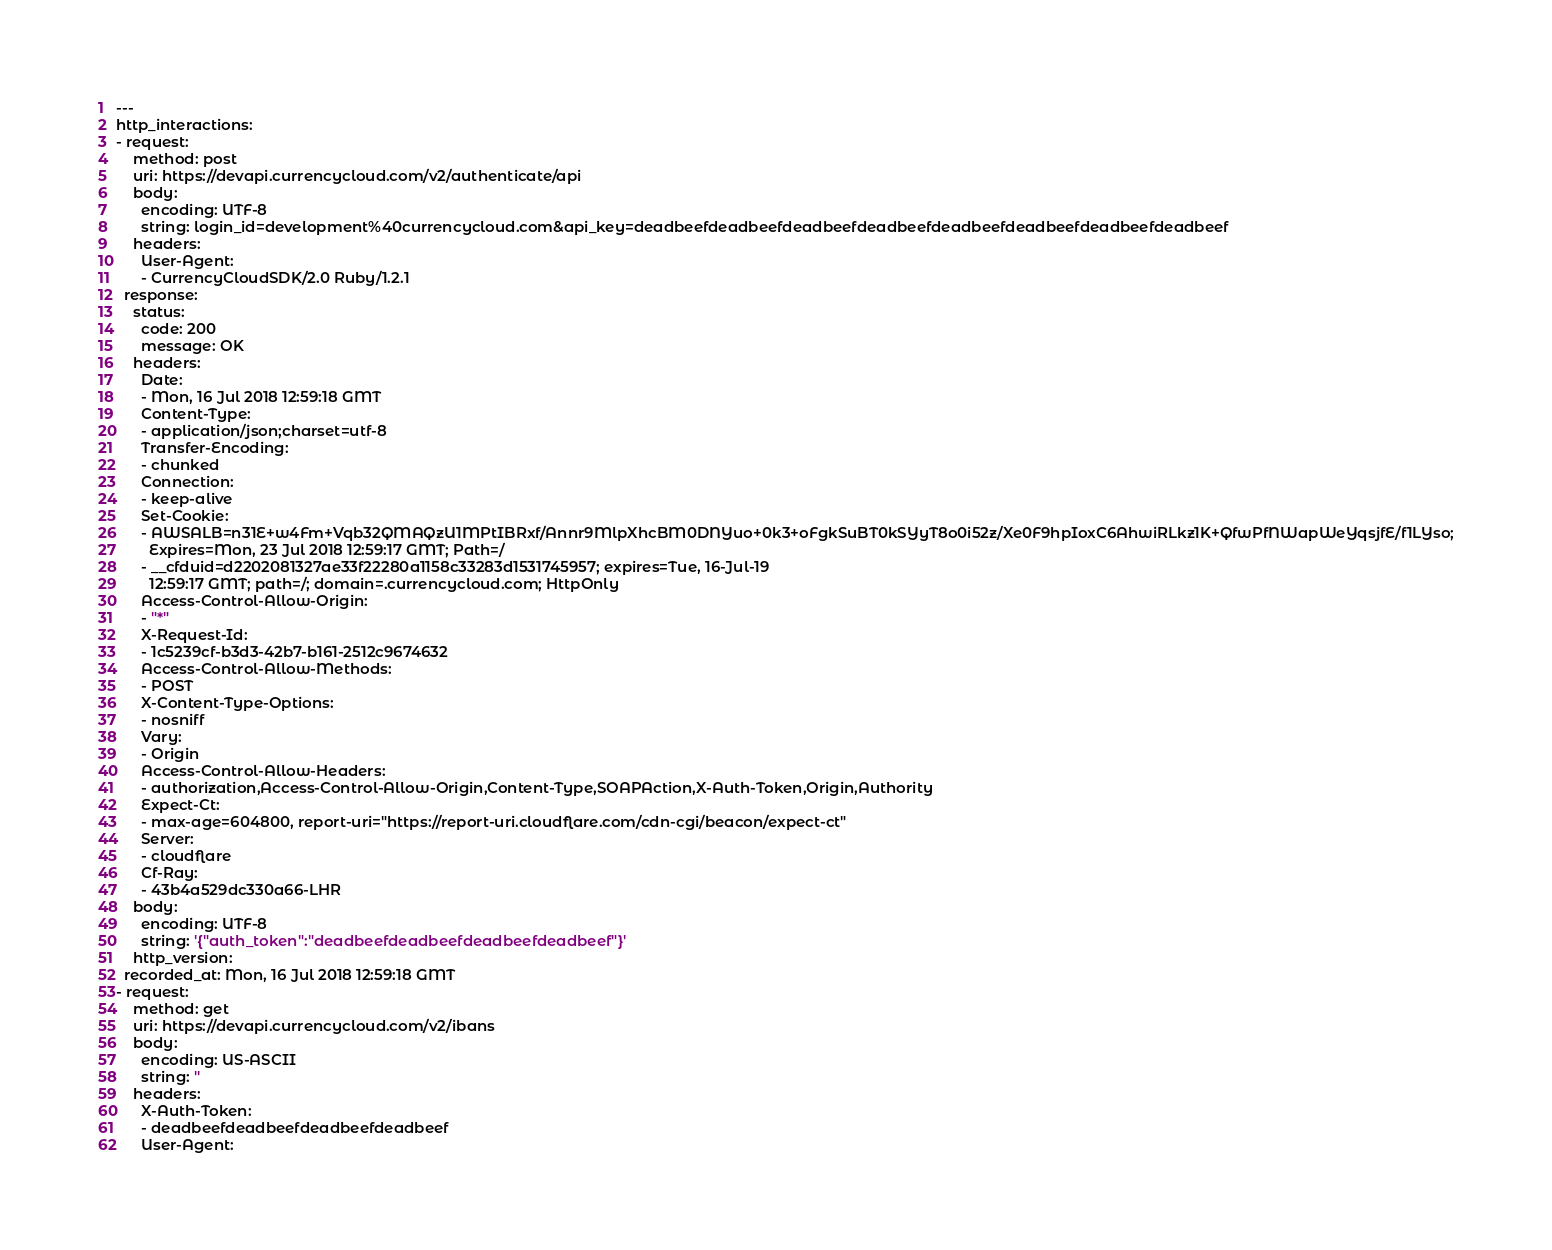Convert code to text. <code><loc_0><loc_0><loc_500><loc_500><_YAML_>---
http_interactions:
- request:
    method: post
    uri: https://devapi.currencycloud.com/v2/authenticate/api
    body:
      encoding: UTF-8
      string: login_id=development%40currencycloud.com&api_key=deadbeefdeadbeefdeadbeefdeadbeefdeadbeefdeadbeefdeadbeefdeadbeef
    headers:
      User-Agent:
      - CurrencyCloudSDK/2.0 Ruby/1.2.1
  response:
    status:
      code: 200
      message: OK
    headers:
      Date:
      - Mon, 16 Jul 2018 12:59:18 GMT
      Content-Type:
      - application/json;charset=utf-8
      Transfer-Encoding:
      - chunked
      Connection:
      - keep-alive
      Set-Cookie:
      - AWSALB=n31E+w4Fm+Vqb32QMAQzU1MPtIBRxf/Annr9MlpXhcBM0DNYuo+0k3+oFgkSuBT0kSYyT8o0i52z/Xe0F9hpIoxC6AhwiRLkz1K+QfwPfNWapWeYqsjfE/f1LYso;
        Expires=Mon, 23 Jul 2018 12:59:17 GMT; Path=/
      - __cfduid=d2202081327ae33f22280a1158c33283d1531745957; expires=Tue, 16-Jul-19
        12:59:17 GMT; path=/; domain=.currencycloud.com; HttpOnly
      Access-Control-Allow-Origin:
      - "*"
      X-Request-Id:
      - 1c5239cf-b3d3-42b7-b161-2512c9674632
      Access-Control-Allow-Methods:
      - POST
      X-Content-Type-Options:
      - nosniff
      Vary:
      - Origin
      Access-Control-Allow-Headers:
      - authorization,Access-Control-Allow-Origin,Content-Type,SOAPAction,X-Auth-Token,Origin,Authority
      Expect-Ct:
      - max-age=604800, report-uri="https://report-uri.cloudflare.com/cdn-cgi/beacon/expect-ct"
      Server:
      - cloudflare
      Cf-Ray:
      - 43b4a529dc330a66-LHR
    body:
      encoding: UTF-8
      string: '{"auth_token":"deadbeefdeadbeefdeadbeefdeadbeef"}'
    http_version:
  recorded_at: Mon, 16 Jul 2018 12:59:18 GMT
- request:
    method: get
    uri: https://devapi.currencycloud.com/v2/ibans
    body:
      encoding: US-ASCII
      string: ''
    headers:
      X-Auth-Token:
      - deadbeefdeadbeefdeadbeefdeadbeef
      User-Agent:</code> 